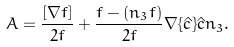Convert formula to latex. <formula><loc_0><loc_0><loc_500><loc_500>A = \frac { [ \nabla f ] } { 2 f } + \frac { f - ( n _ { 3 } f ) } { 2 f } \nabla \{ \hat { c } \} \hat { c } n _ { 3 } .</formula> 